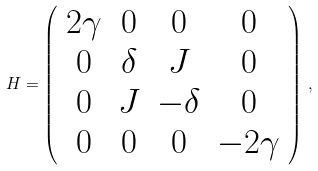<formula> <loc_0><loc_0><loc_500><loc_500>H = \left ( \begin{array} { c c c c } 2 \gamma & 0 & 0 & 0 \\ 0 & \delta & J & 0 \\ 0 & J & - \delta & 0 \\ 0 & 0 & 0 & - 2 \gamma \end{array} \right ) \, ,</formula> 